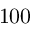<formula> <loc_0><loc_0><loc_500><loc_500>1 0 0</formula> 